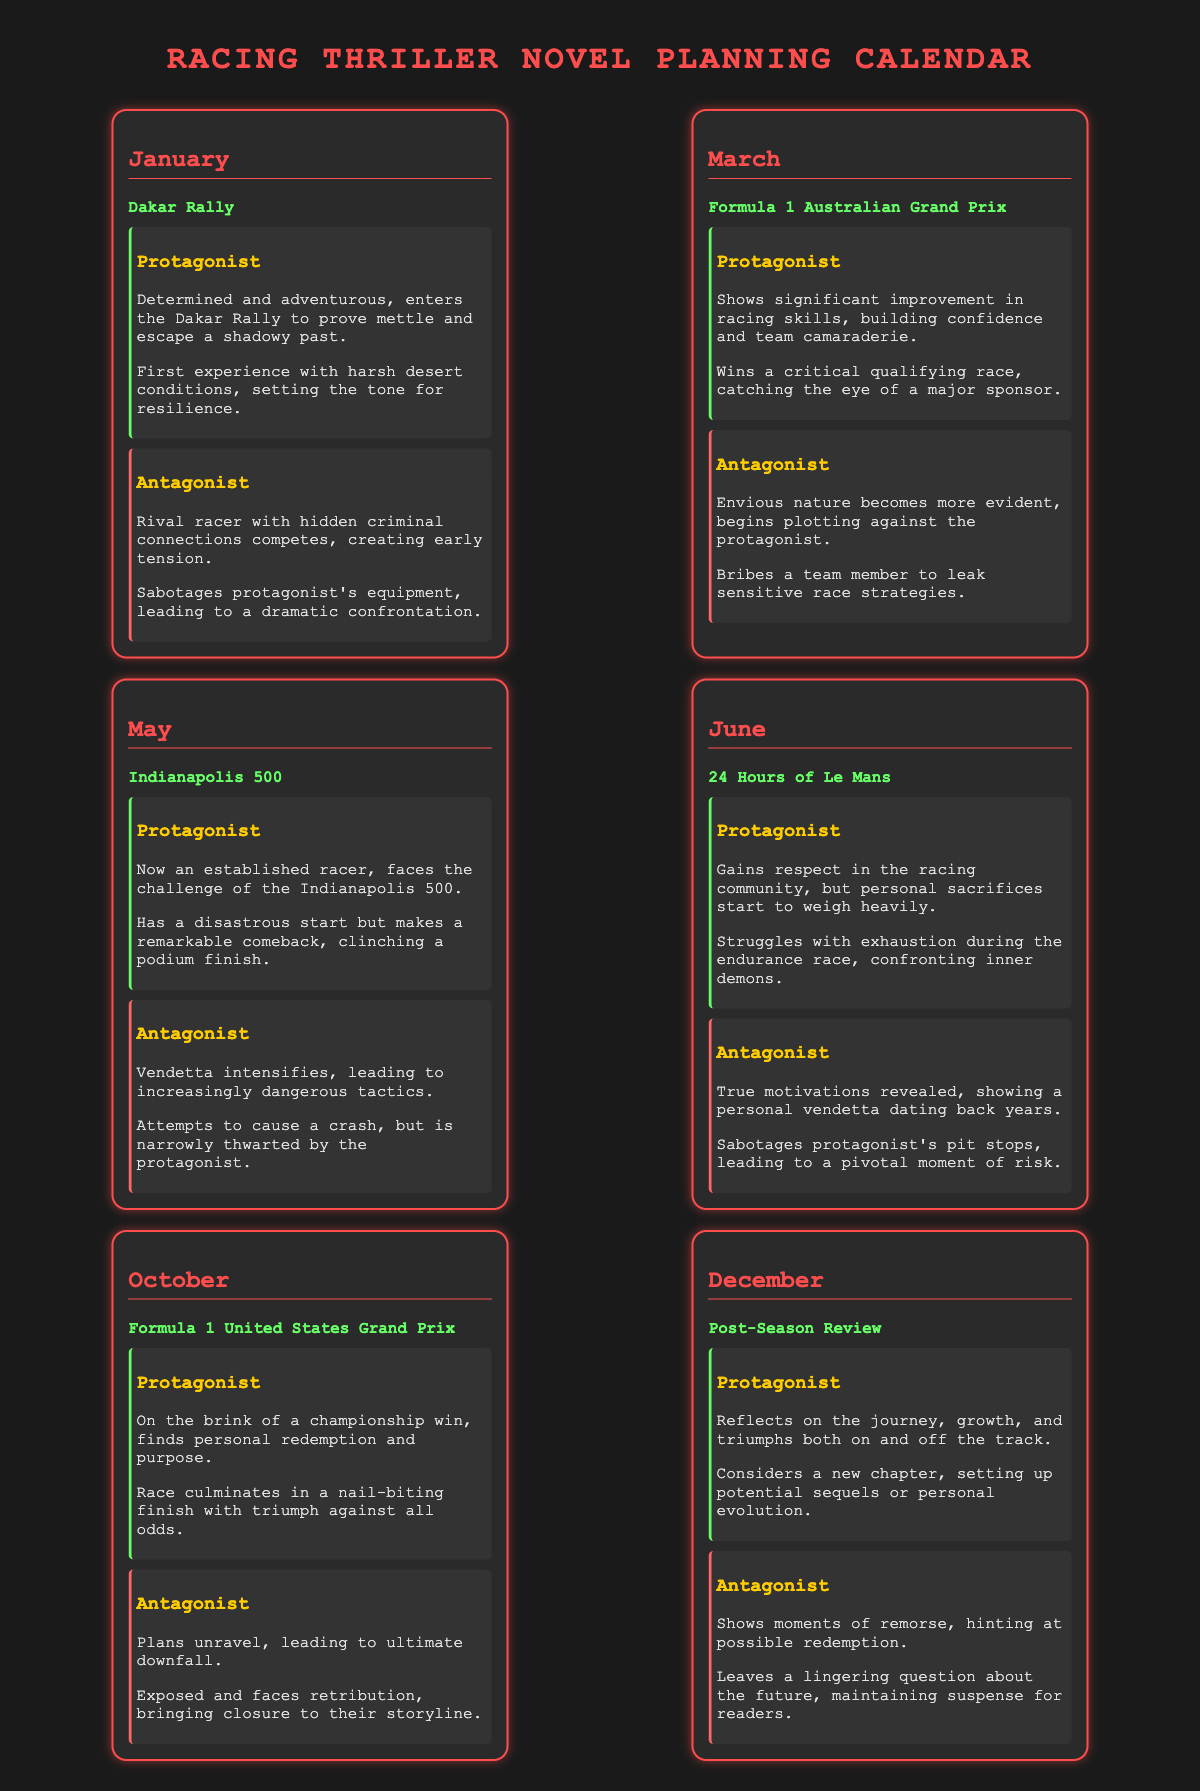What event takes place in January? The event listed for January is the Dakar Rally.
Answer: Dakar Rally Who is the protagonist in June? The protagonist in June is described as gaining respect in the racing community and struggling with exhaustion.
Answer: Gaining respect and struggling with exhaustion What critical race does the protagonist win in March? The key race that the protagonist wins in March is the qualifying race before the Formula 1 Australian Grand Prix.
Answer: Qualifying race What happens to the antagonist at the end of October? At the end of October, the antagonist's plans unravel, leading to their ultimate downfall.
Answer: Ultimate downfall How many major racing events are listed in the calendar? The document features five major racing events throughout the year.
Answer: Five What does the protagonist reflect on in December? In December, the protagonist reflects on their journey, growth, and triumphs.
Answer: Journey, growth, and triumphs What milestone occurs at the Indianapolis 500? A significant milestone for the protagonist at the Indianapolis 500 is a remarkable comeback that leads to a podium finish.
Answer: Remarkable comeback to podium finish What is the relationship between the protagonist and antagonist throughout the events? The relationship shows increasing tension and confrontation as the antagonist plots against the protagonist.
Answer: Increasing tension and confrontation 